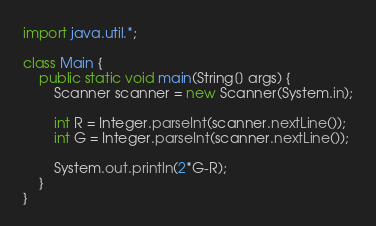Convert code to text. <code><loc_0><loc_0><loc_500><loc_500><_Java_>import java.util.*;

class Main {
	public static void main(String[] args) {
		Scanner scanner = new Scanner(System.in);
		
		int R = Integer.parseInt(scanner.nextLine());
		int G = Integer.parseInt(scanner.nextLine());
		
		System.out.println(2*G-R);
	}
}
</code> 